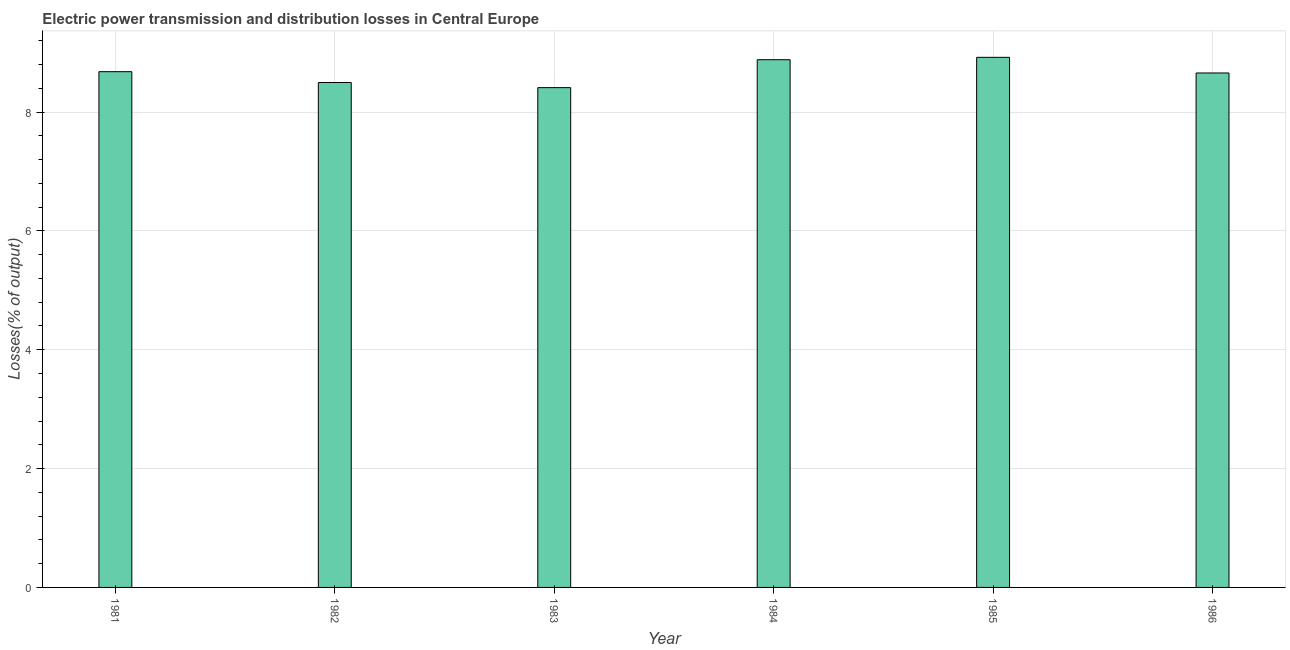Does the graph contain any zero values?
Your answer should be very brief. No. What is the title of the graph?
Provide a succinct answer. Electric power transmission and distribution losses in Central Europe. What is the label or title of the X-axis?
Offer a terse response. Year. What is the label or title of the Y-axis?
Offer a very short reply. Losses(% of output). What is the electric power transmission and distribution losses in 1981?
Keep it short and to the point. 8.68. Across all years, what is the maximum electric power transmission and distribution losses?
Your response must be concise. 8.92. Across all years, what is the minimum electric power transmission and distribution losses?
Provide a short and direct response. 8.41. What is the sum of the electric power transmission and distribution losses?
Give a very brief answer. 52.05. What is the difference between the electric power transmission and distribution losses in 1981 and 1982?
Provide a short and direct response. 0.18. What is the average electric power transmission and distribution losses per year?
Provide a short and direct response. 8.67. What is the median electric power transmission and distribution losses?
Give a very brief answer. 8.67. Do a majority of the years between 1982 and 1981 (inclusive) have electric power transmission and distribution losses greater than 8.4 %?
Your response must be concise. No. What is the ratio of the electric power transmission and distribution losses in 1981 to that in 1985?
Keep it short and to the point. 0.97. Is the electric power transmission and distribution losses in 1983 less than that in 1984?
Make the answer very short. Yes. Is the difference between the electric power transmission and distribution losses in 1984 and 1985 greater than the difference between any two years?
Provide a short and direct response. No. What is the difference between the highest and the second highest electric power transmission and distribution losses?
Give a very brief answer. 0.04. What is the difference between the highest and the lowest electric power transmission and distribution losses?
Ensure brevity in your answer.  0.51. How many bars are there?
Provide a succinct answer. 6. Are all the bars in the graph horizontal?
Keep it short and to the point. No. How many years are there in the graph?
Your answer should be compact. 6. What is the difference between two consecutive major ticks on the Y-axis?
Make the answer very short. 2. What is the Losses(% of output) of 1981?
Make the answer very short. 8.68. What is the Losses(% of output) of 1982?
Give a very brief answer. 8.5. What is the Losses(% of output) of 1983?
Your answer should be compact. 8.41. What is the Losses(% of output) in 1984?
Provide a succinct answer. 8.88. What is the Losses(% of output) of 1985?
Provide a short and direct response. 8.92. What is the Losses(% of output) in 1986?
Your answer should be compact. 8.66. What is the difference between the Losses(% of output) in 1981 and 1982?
Your answer should be very brief. 0.18. What is the difference between the Losses(% of output) in 1981 and 1983?
Provide a succinct answer. 0.27. What is the difference between the Losses(% of output) in 1981 and 1984?
Your response must be concise. -0.2. What is the difference between the Losses(% of output) in 1981 and 1985?
Give a very brief answer. -0.24. What is the difference between the Losses(% of output) in 1981 and 1986?
Your response must be concise. 0.02. What is the difference between the Losses(% of output) in 1982 and 1983?
Keep it short and to the point. 0.09. What is the difference between the Losses(% of output) in 1982 and 1984?
Provide a succinct answer. -0.38. What is the difference between the Losses(% of output) in 1982 and 1985?
Provide a short and direct response. -0.42. What is the difference between the Losses(% of output) in 1982 and 1986?
Ensure brevity in your answer.  -0.16. What is the difference between the Losses(% of output) in 1983 and 1984?
Offer a very short reply. -0.47. What is the difference between the Losses(% of output) in 1983 and 1985?
Your answer should be compact. -0.51. What is the difference between the Losses(% of output) in 1983 and 1986?
Provide a succinct answer. -0.25. What is the difference between the Losses(% of output) in 1984 and 1985?
Your answer should be very brief. -0.04. What is the difference between the Losses(% of output) in 1984 and 1986?
Offer a very short reply. 0.22. What is the difference between the Losses(% of output) in 1985 and 1986?
Offer a terse response. 0.26. What is the ratio of the Losses(% of output) in 1981 to that in 1982?
Give a very brief answer. 1.02. What is the ratio of the Losses(% of output) in 1981 to that in 1983?
Provide a short and direct response. 1.03. What is the ratio of the Losses(% of output) in 1981 to that in 1985?
Offer a very short reply. 0.97. What is the ratio of the Losses(% of output) in 1981 to that in 1986?
Your answer should be compact. 1. What is the ratio of the Losses(% of output) in 1982 to that in 1984?
Offer a terse response. 0.96. What is the ratio of the Losses(% of output) in 1982 to that in 1985?
Provide a short and direct response. 0.95. What is the ratio of the Losses(% of output) in 1983 to that in 1984?
Provide a succinct answer. 0.95. What is the ratio of the Losses(% of output) in 1983 to that in 1985?
Your response must be concise. 0.94. What is the ratio of the Losses(% of output) in 1983 to that in 1986?
Ensure brevity in your answer.  0.97. 